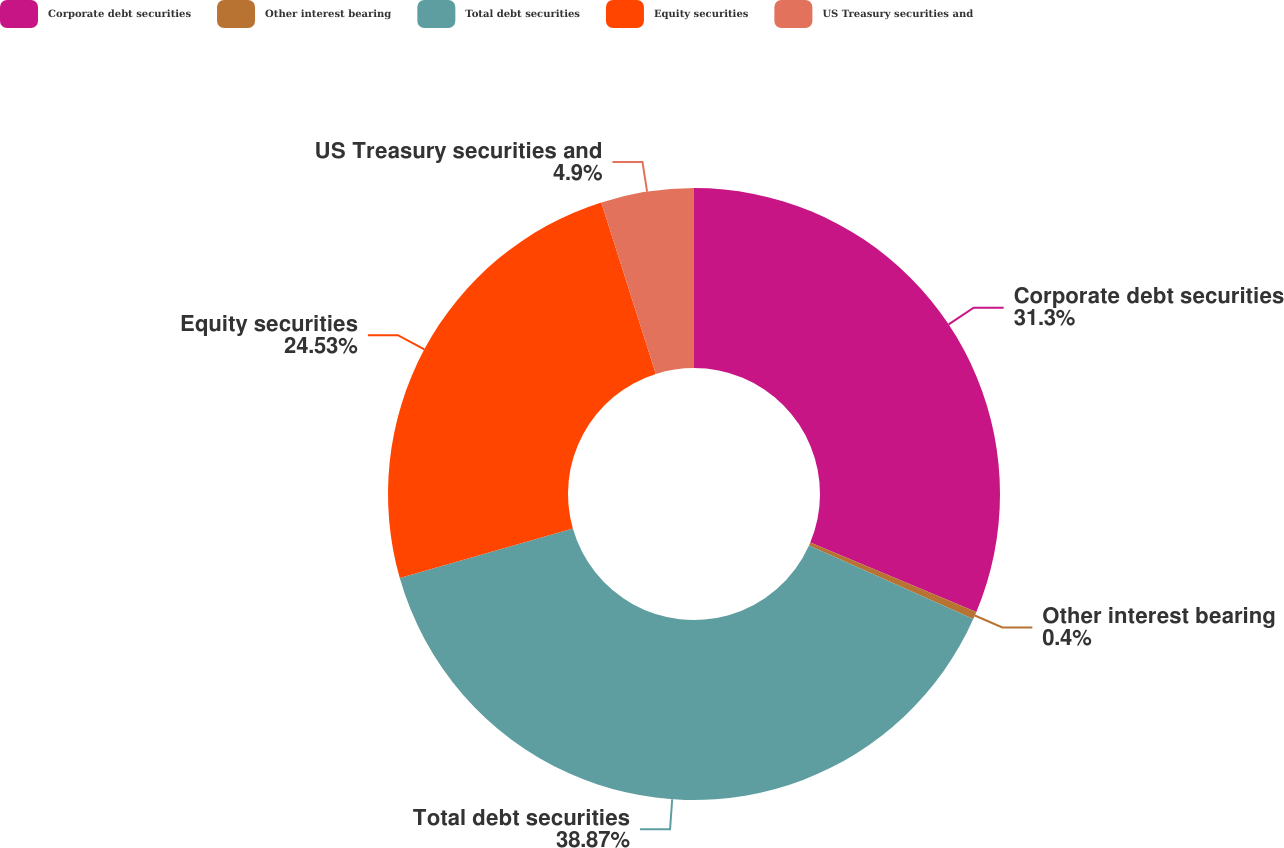Convert chart. <chart><loc_0><loc_0><loc_500><loc_500><pie_chart><fcel>Corporate debt securities<fcel>Other interest bearing<fcel>Total debt securities<fcel>Equity securities<fcel>US Treasury securities and<nl><fcel>31.3%<fcel>0.4%<fcel>38.87%<fcel>24.53%<fcel>4.9%<nl></chart> 